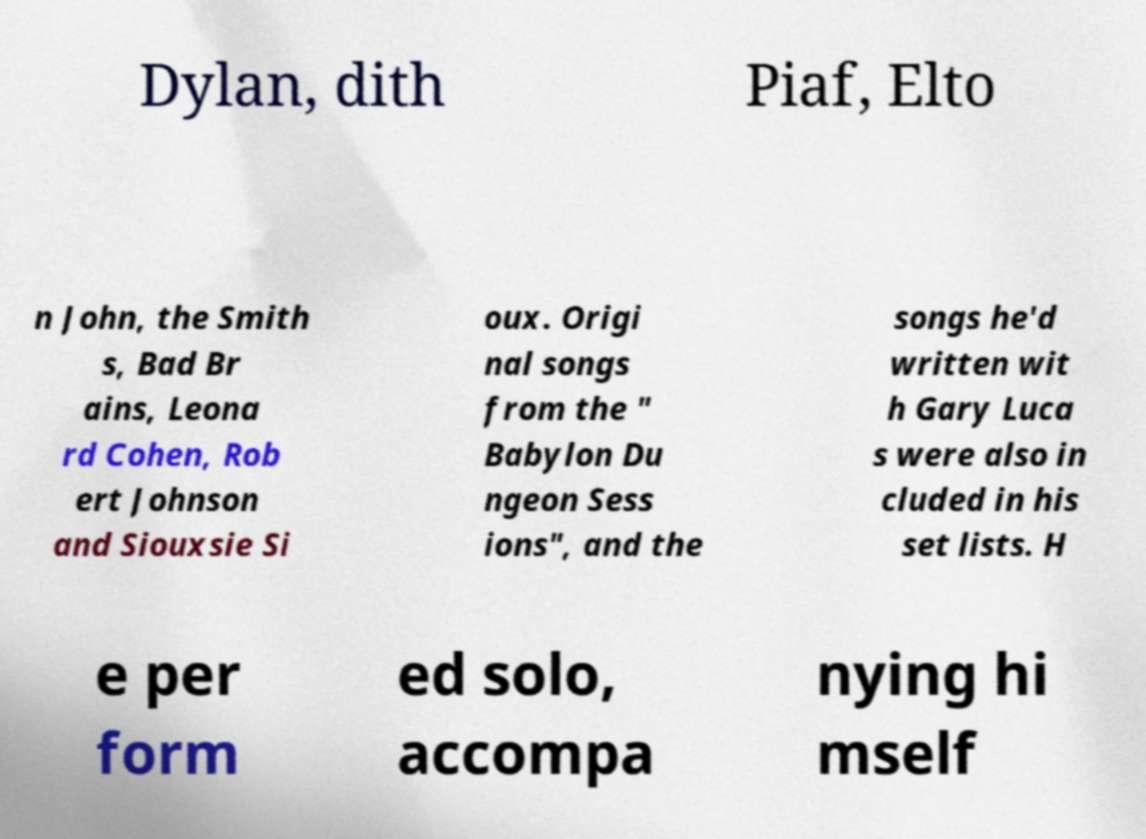I need the written content from this picture converted into text. Can you do that? Dylan, dith Piaf, Elto n John, the Smith s, Bad Br ains, Leona rd Cohen, Rob ert Johnson and Siouxsie Si oux. Origi nal songs from the " Babylon Du ngeon Sess ions", and the songs he'd written wit h Gary Luca s were also in cluded in his set lists. H e per form ed solo, accompa nying hi mself 